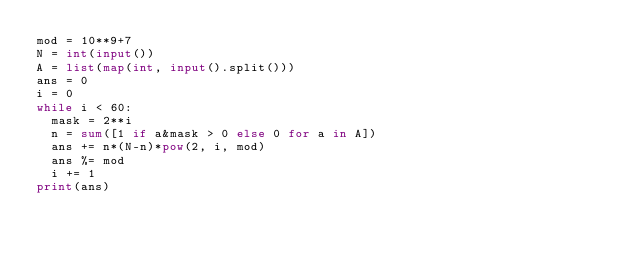<code> <loc_0><loc_0><loc_500><loc_500><_Python_>mod = 10**9+7
N = int(input())
A = list(map(int, input().split()))
ans = 0
i = 0
while i < 60:
  mask = 2**i
  n = sum([1 if a&mask > 0 else 0 for a in A])
  ans += n*(N-n)*pow(2, i, mod)
  ans %= mod
  i += 1
print(ans)</code> 